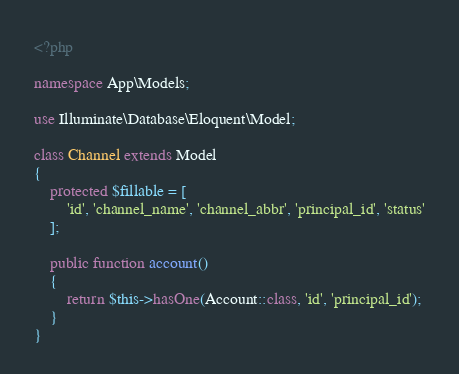<code> <loc_0><loc_0><loc_500><loc_500><_PHP_><?php

namespace App\Models;

use Illuminate\Database\Eloquent\Model;

class Channel extends Model
{
    protected $fillable = [
        'id', 'channel_name', 'channel_abbr', 'principal_id', 'status'
    ];

    public function account()
    {
        return $this->hasOne(Account::class, 'id', 'principal_id');
    }
}</code> 